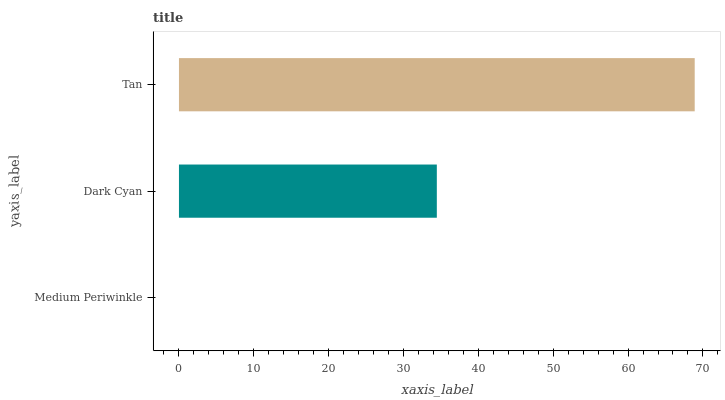Is Medium Periwinkle the minimum?
Answer yes or no. Yes. Is Tan the maximum?
Answer yes or no. Yes. Is Dark Cyan the minimum?
Answer yes or no. No. Is Dark Cyan the maximum?
Answer yes or no. No. Is Dark Cyan greater than Medium Periwinkle?
Answer yes or no. Yes. Is Medium Periwinkle less than Dark Cyan?
Answer yes or no. Yes. Is Medium Periwinkle greater than Dark Cyan?
Answer yes or no. No. Is Dark Cyan less than Medium Periwinkle?
Answer yes or no. No. Is Dark Cyan the high median?
Answer yes or no. Yes. Is Dark Cyan the low median?
Answer yes or no. Yes. Is Tan the high median?
Answer yes or no. No. Is Tan the low median?
Answer yes or no. No. 